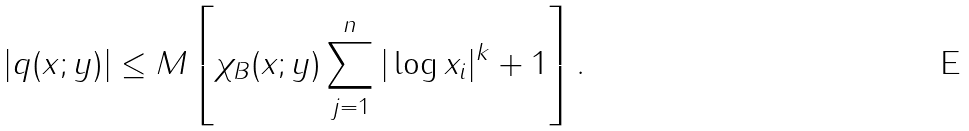Convert formula to latex. <formula><loc_0><loc_0><loc_500><loc_500>| q ( x ; y ) | \leq M \left [ \chi _ { B } ( x ; y ) \sum _ { j = 1 } ^ { n } | \log x _ { i } | ^ { k } + 1 \right ] .</formula> 